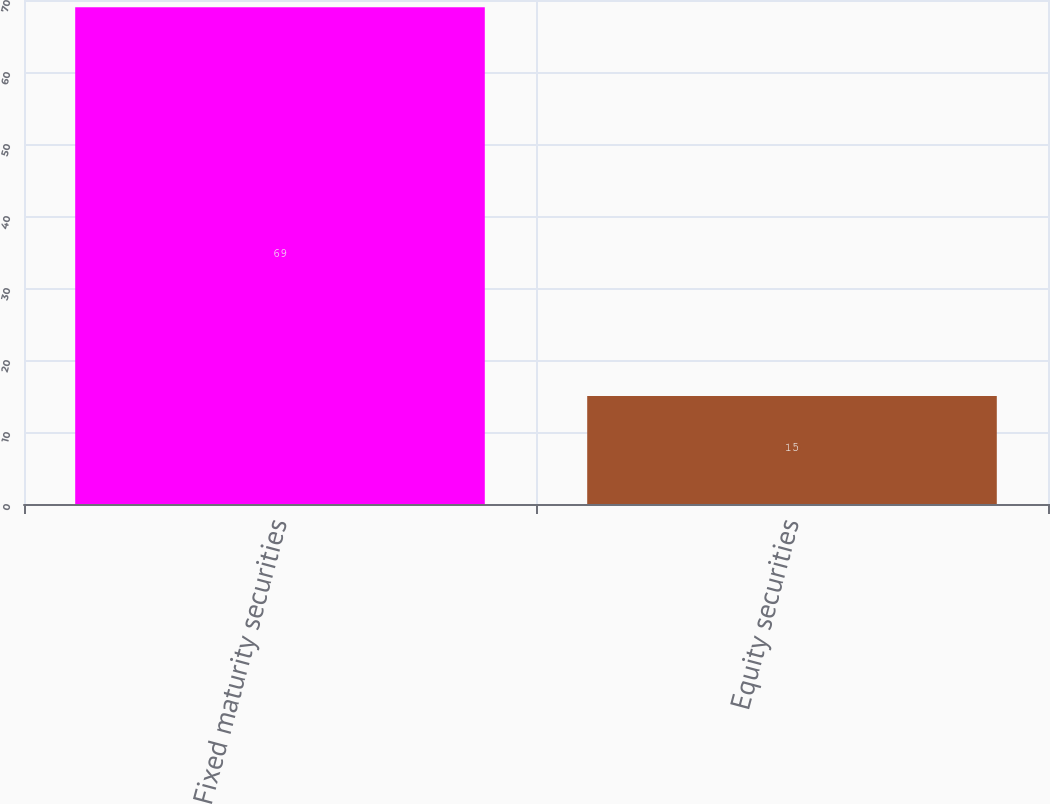Convert chart to OTSL. <chart><loc_0><loc_0><loc_500><loc_500><bar_chart><fcel>Fixed maturity securities<fcel>Equity securities<nl><fcel>69<fcel>15<nl></chart> 